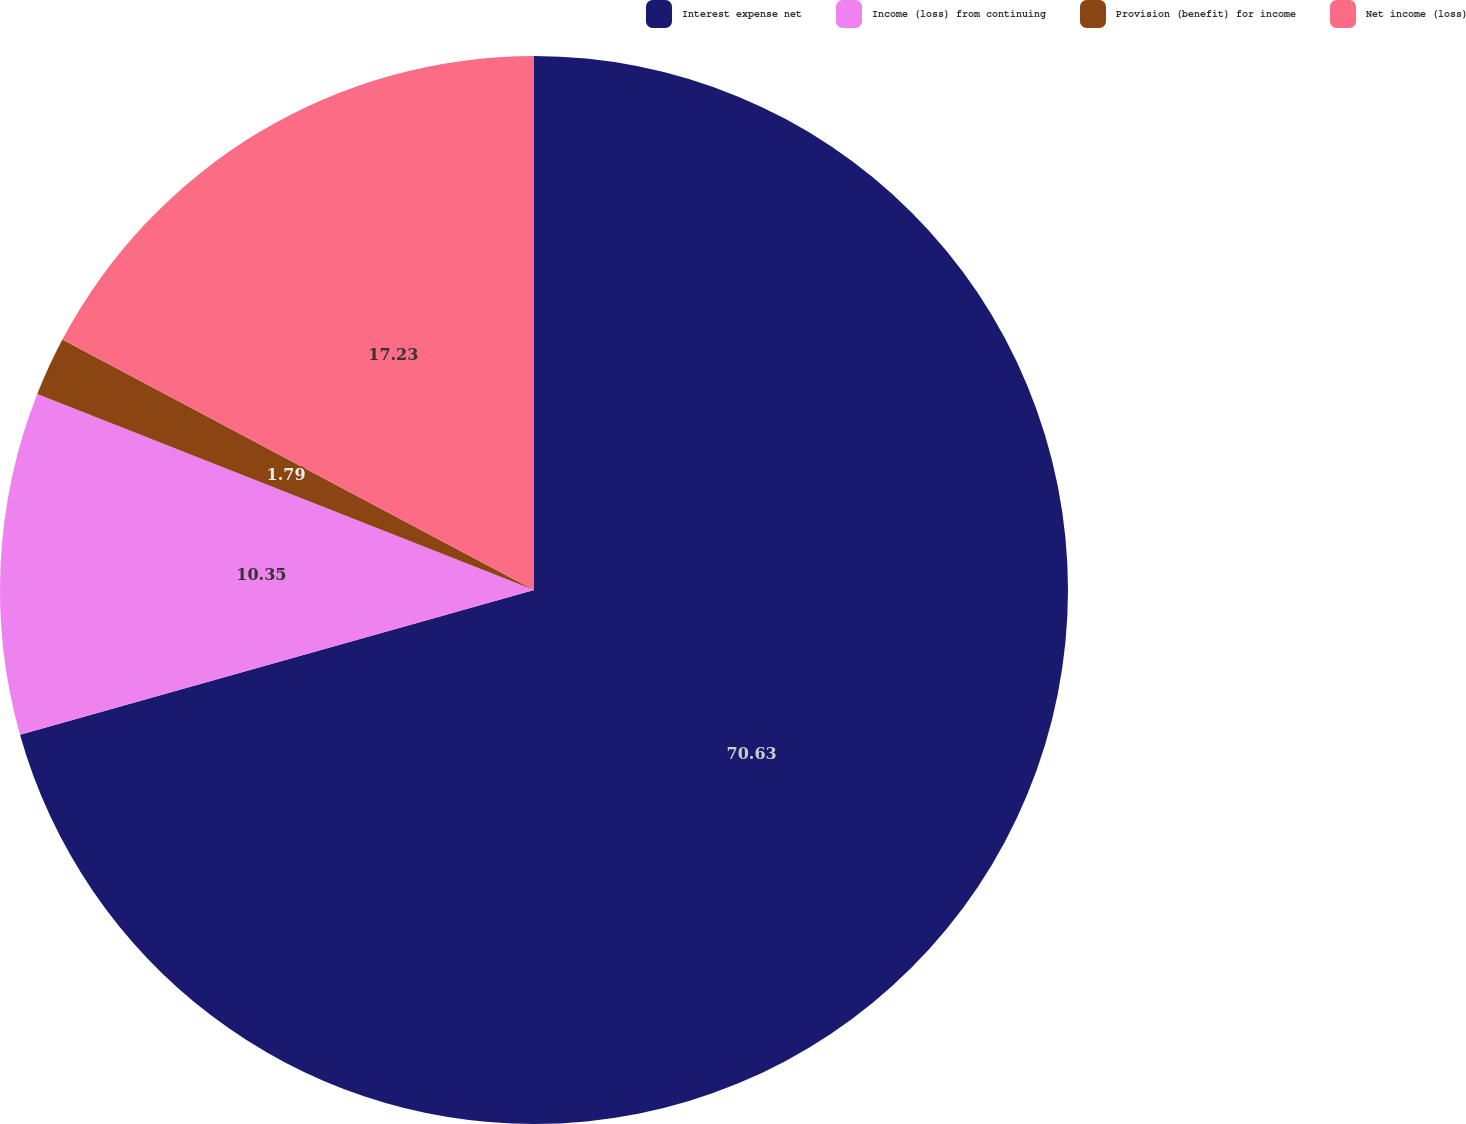<chart> <loc_0><loc_0><loc_500><loc_500><pie_chart><fcel>Interest expense net<fcel>Income (loss) from continuing<fcel>Provision (benefit) for income<fcel>Net income (loss)<nl><fcel>70.63%<fcel>10.35%<fcel>1.79%<fcel>17.23%<nl></chart> 